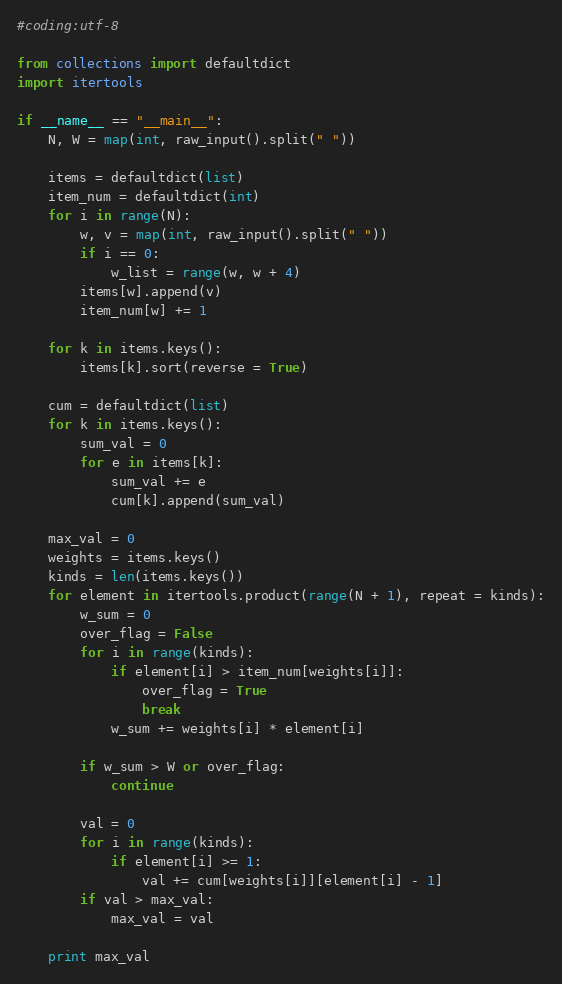Convert code to text. <code><loc_0><loc_0><loc_500><loc_500><_Python_>#coding:utf-8

from collections import defaultdict
import itertools

if __name__ == "__main__":
    N, W = map(int, raw_input().split(" "))

    items = defaultdict(list)
    item_num = defaultdict(int)
    for i in range(N):
        w, v = map(int, raw_input().split(" "))
        if i == 0:
            w_list = range(w, w + 4)
        items[w].append(v)
        item_num[w] += 1

    for k in items.keys():
        items[k].sort(reverse = True)

    cum = defaultdict(list)
    for k in items.keys():
        sum_val = 0
        for e in items[k]:
            sum_val += e
            cum[k].append(sum_val)

    max_val = 0
    weights = items.keys()
    kinds = len(items.keys())
    for element in itertools.product(range(N + 1), repeat = kinds):
        w_sum = 0
        over_flag = False
        for i in range(kinds):
            if element[i] > item_num[weights[i]]:
                over_flag = True
                break
            w_sum += weights[i] * element[i]

        if w_sum > W or over_flag:
            continue

        val = 0
        for i in range(kinds):
            if element[i] >= 1:
                val += cum[weights[i]][element[i] - 1]
        if val > max_val:
            max_val = val

    print max_val
</code> 